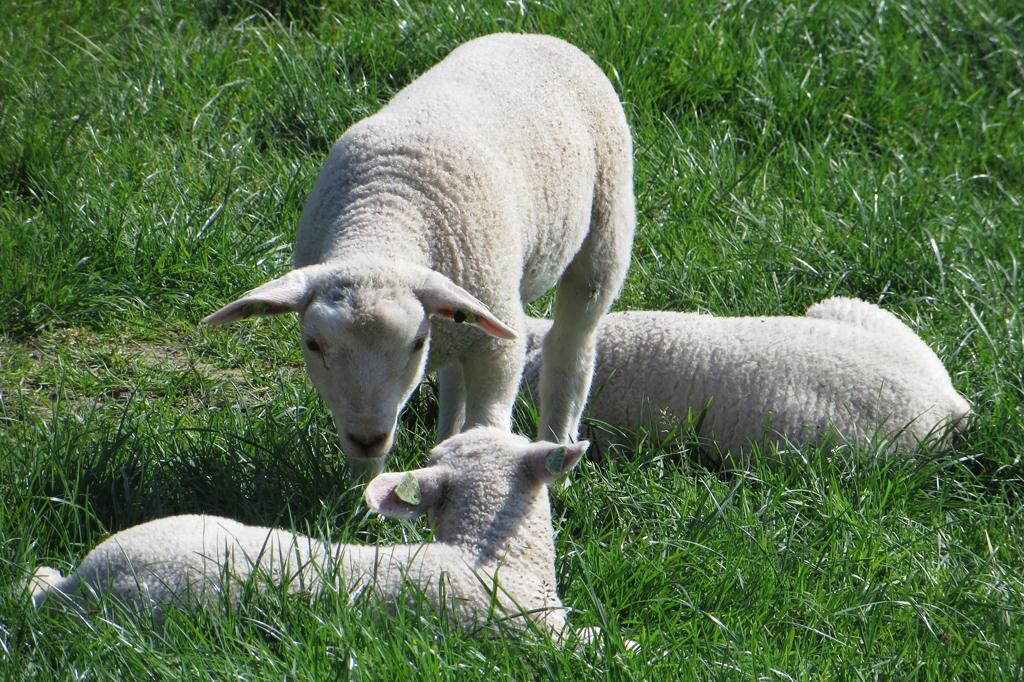Can you describe this image briefly? In this picture we can see a white color sheep standing in the middle of the ground. Beside there are two more sheep sitting on the grass ground. 